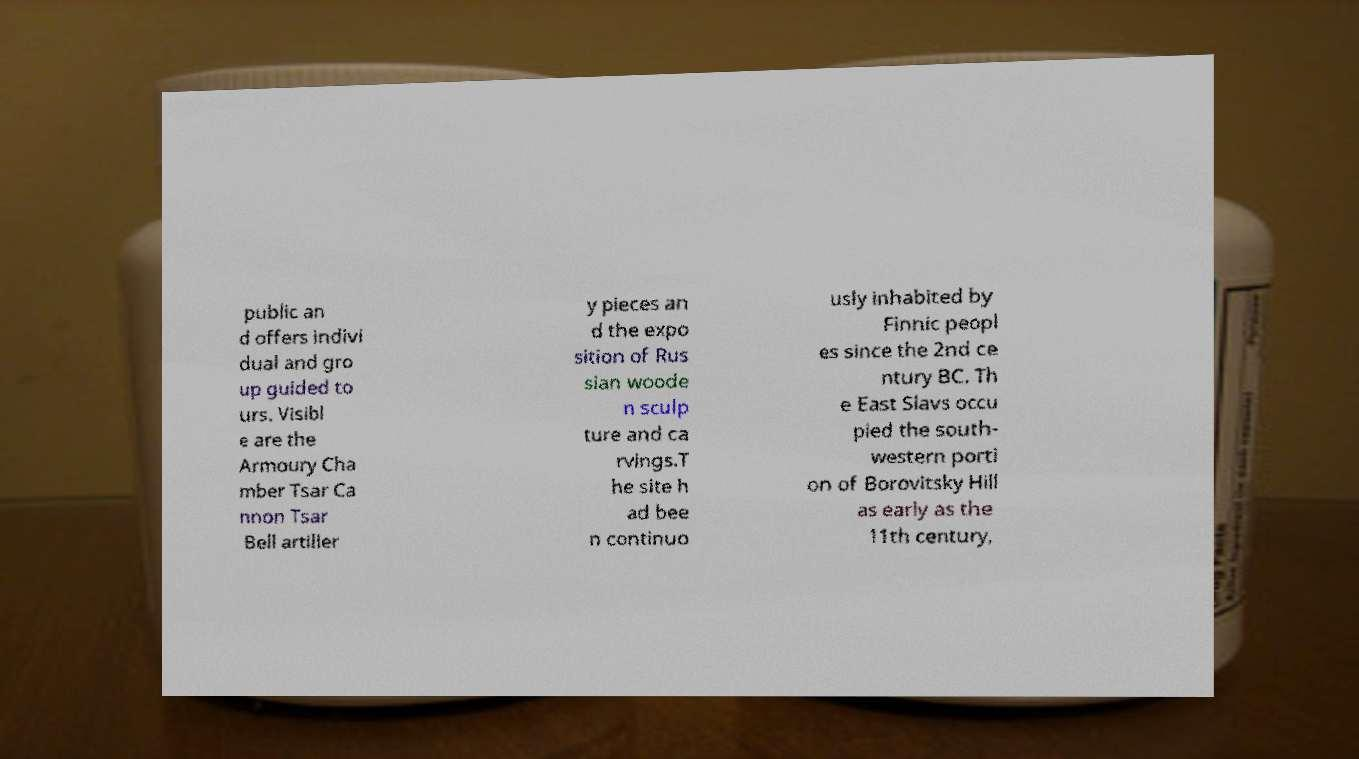For documentation purposes, I need the text within this image transcribed. Could you provide that? public an d offers indivi dual and gro up guided to urs. Visibl e are the Armoury Cha mber Tsar Ca nnon Tsar Bell artiller y pieces an d the expo sition of Rus sian woode n sculp ture and ca rvings.T he site h ad bee n continuo usly inhabited by Finnic peopl es since the 2nd ce ntury BC. Th e East Slavs occu pied the south- western porti on of Borovitsky Hill as early as the 11th century, 